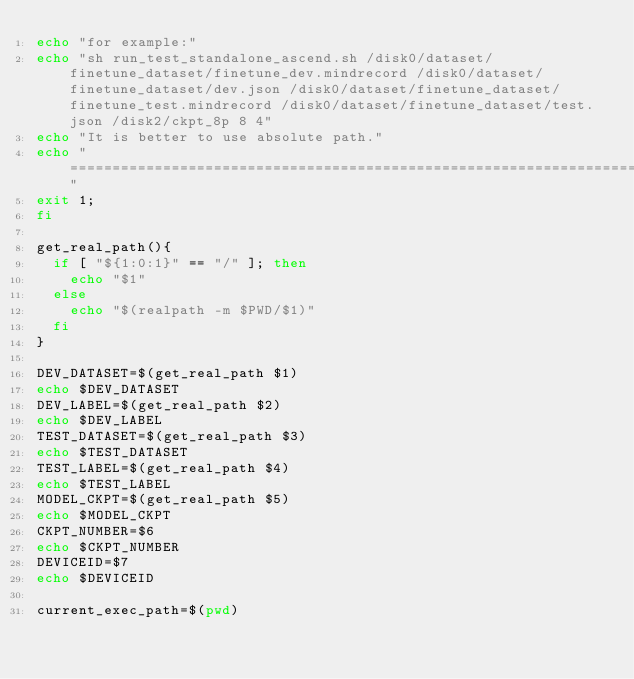<code> <loc_0><loc_0><loc_500><loc_500><_Bash_>echo "for example:"
echo "sh run_test_standalone_ascend.sh /disk0/dataset/finetune_dataset/finetune_dev.mindrecord /disk0/dataset/finetune_dataset/dev.json /disk0/dataset/finetune_dataset/finetune_test.mindrecord /disk0/dataset/finetune_dataset/test.json /disk2/ckpt_8p 8 4"
echo "It is better to use absolute path."
echo "=============================================================================================================="
exit 1;
fi

get_real_path(){
  if [ "${1:0:1}" == "/" ]; then
    echo "$1"
  else
    echo "$(realpath -m $PWD/$1)"
  fi
}

DEV_DATASET=$(get_real_path $1)
echo $DEV_DATASET
DEV_LABEL=$(get_real_path $2)
echo $DEV_LABEL
TEST_DATASET=$(get_real_path $3)
echo $TEST_DATASET
TEST_LABEL=$(get_real_path $4)
echo $TEST_LABEL
MODEL_CKPT=$(get_real_path $5)
echo $MODEL_CKPT
CKPT_NUMBER=$6
echo $CKPT_NUMBER
DEVICEID=$7
echo $DEVICEID

current_exec_path=$(pwd)</code> 